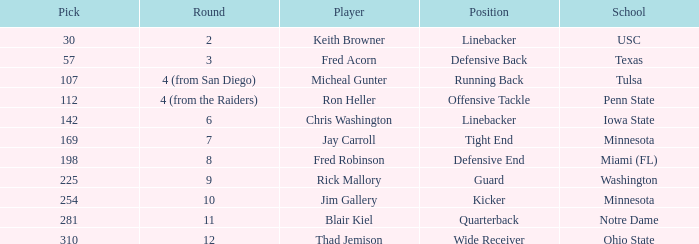What is the cumulative draft position for a wide receiver? 1.0. Would you mind parsing the complete table? {'header': ['Pick', 'Round', 'Player', 'Position', 'School'], 'rows': [['30', '2', 'Keith Browner', 'Linebacker', 'USC'], ['57', '3', 'Fred Acorn', 'Defensive Back', 'Texas'], ['107', '4 (from San Diego)', 'Micheal Gunter', 'Running Back', 'Tulsa'], ['112', '4 (from the Raiders)', 'Ron Heller', 'Offensive Tackle', 'Penn State'], ['142', '6', 'Chris Washington', 'Linebacker', 'Iowa State'], ['169', '7', 'Jay Carroll', 'Tight End', 'Minnesota'], ['198', '8', 'Fred Robinson', 'Defensive End', 'Miami (FL)'], ['225', '9', 'Rick Mallory', 'Guard', 'Washington'], ['254', '10', 'Jim Gallery', 'Kicker', 'Minnesota'], ['281', '11', 'Blair Kiel', 'Quarterback', 'Notre Dame'], ['310', '12', 'Thad Jemison', 'Wide Receiver', 'Ohio State']]} 